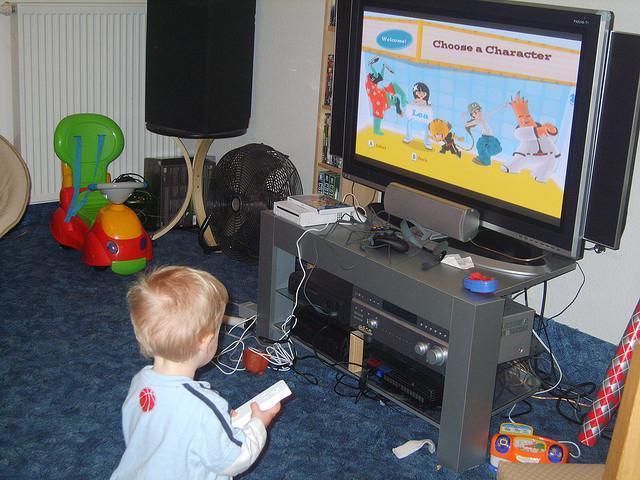How many cats with green eyes are there?
Give a very brief answer. 0. 